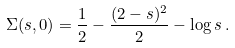Convert formula to latex. <formula><loc_0><loc_0><loc_500><loc_500>\Sigma ( s , 0 ) = \frac { 1 } { 2 } - \frac { ( 2 - s ) ^ { 2 } } { 2 } - \log s \, .</formula> 